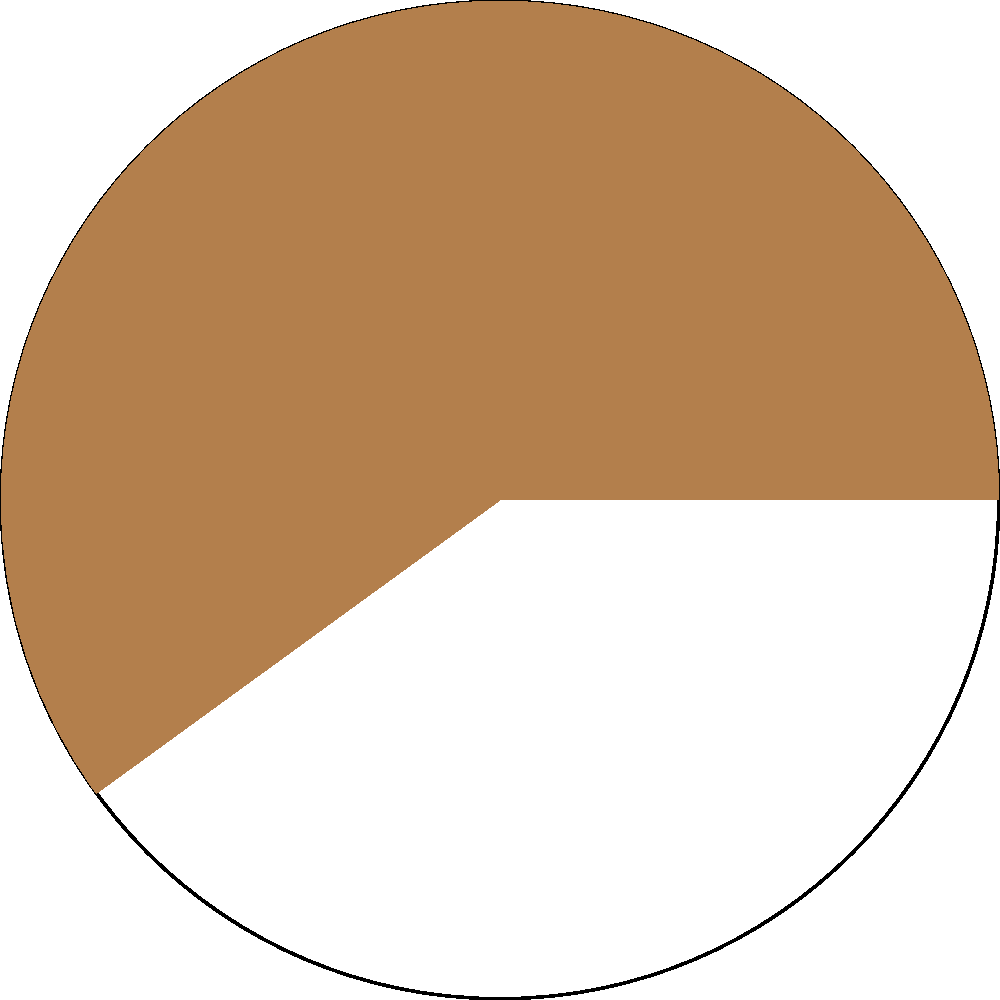In a circular pie chart representing coffee sourcing, the ethically sourced coffee is shown as a sector. If the central angle of this sector is $216°$, what percentage of the total area does the ethically sourced coffee represent? To solve this problem, we'll follow these steps:

1) Recall that the area of a sector is proportional to its central angle.

2) The full circle represents 100% of the coffee and corresponds to $360°$.

3) Set up a proportion:
   $$\frac{\text{Sector Angle}}{\text{Full Circle Angle}} = \frac{\text{Sector Percentage}}{\text{Full Circle Percentage}}$$

4) Substitute the known values:
   $$\frac{216°}{360°} = \frac{x}{100\%}$$

5) Cross multiply:
   $$216 * 100 = 360x$$

6) Solve for $x$:
   $$x = \frac{216 * 100}{360} = 60$$

Therefore, the ethically sourced coffee represents 60% of the total.
Answer: 60% 